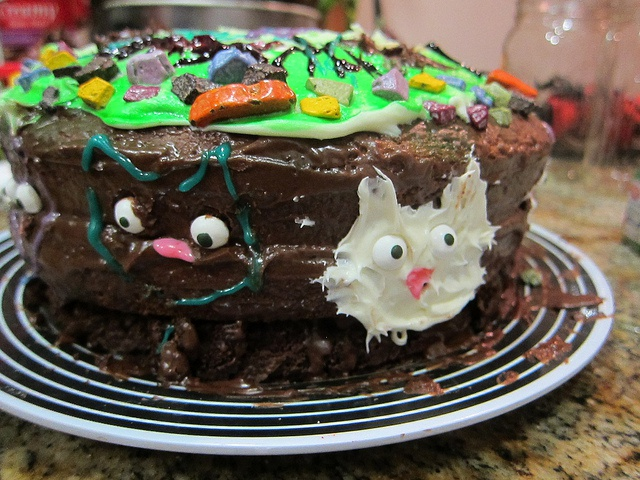Describe the objects in this image and their specific colors. I can see cake in gray, black, darkgray, and maroon tones and cat in gray, darkgray, lightgray, and tan tones in this image. 